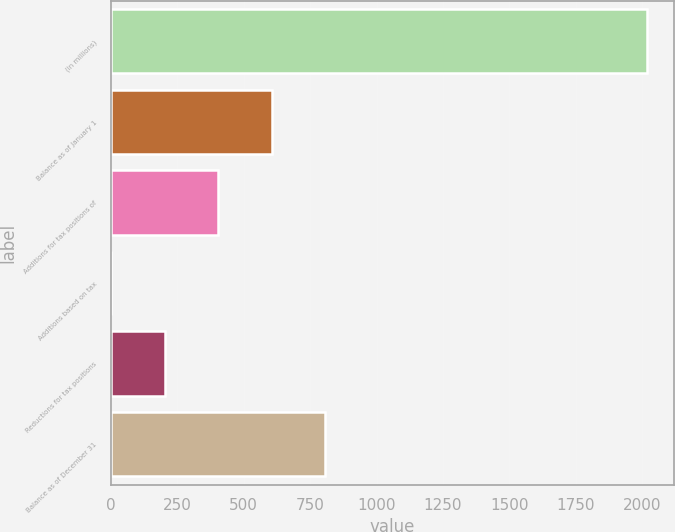Convert chart to OTSL. <chart><loc_0><loc_0><loc_500><loc_500><bar_chart><fcel>(in millions)<fcel>Balance as of January 1<fcel>Additions for tax positions of<fcel>Additions based on tax<fcel>Reductions for tax positions<fcel>Balance as of December 31<nl><fcel>2018<fcel>605.47<fcel>403.68<fcel>0.1<fcel>201.89<fcel>807.26<nl></chart> 